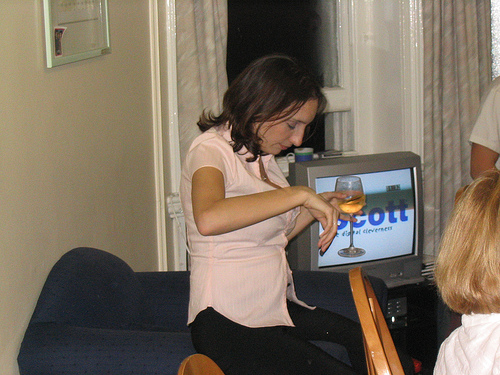<image>
Can you confirm if the cup is in front of the television? Yes. The cup is positioned in front of the television, appearing closer to the camera viewpoint. 